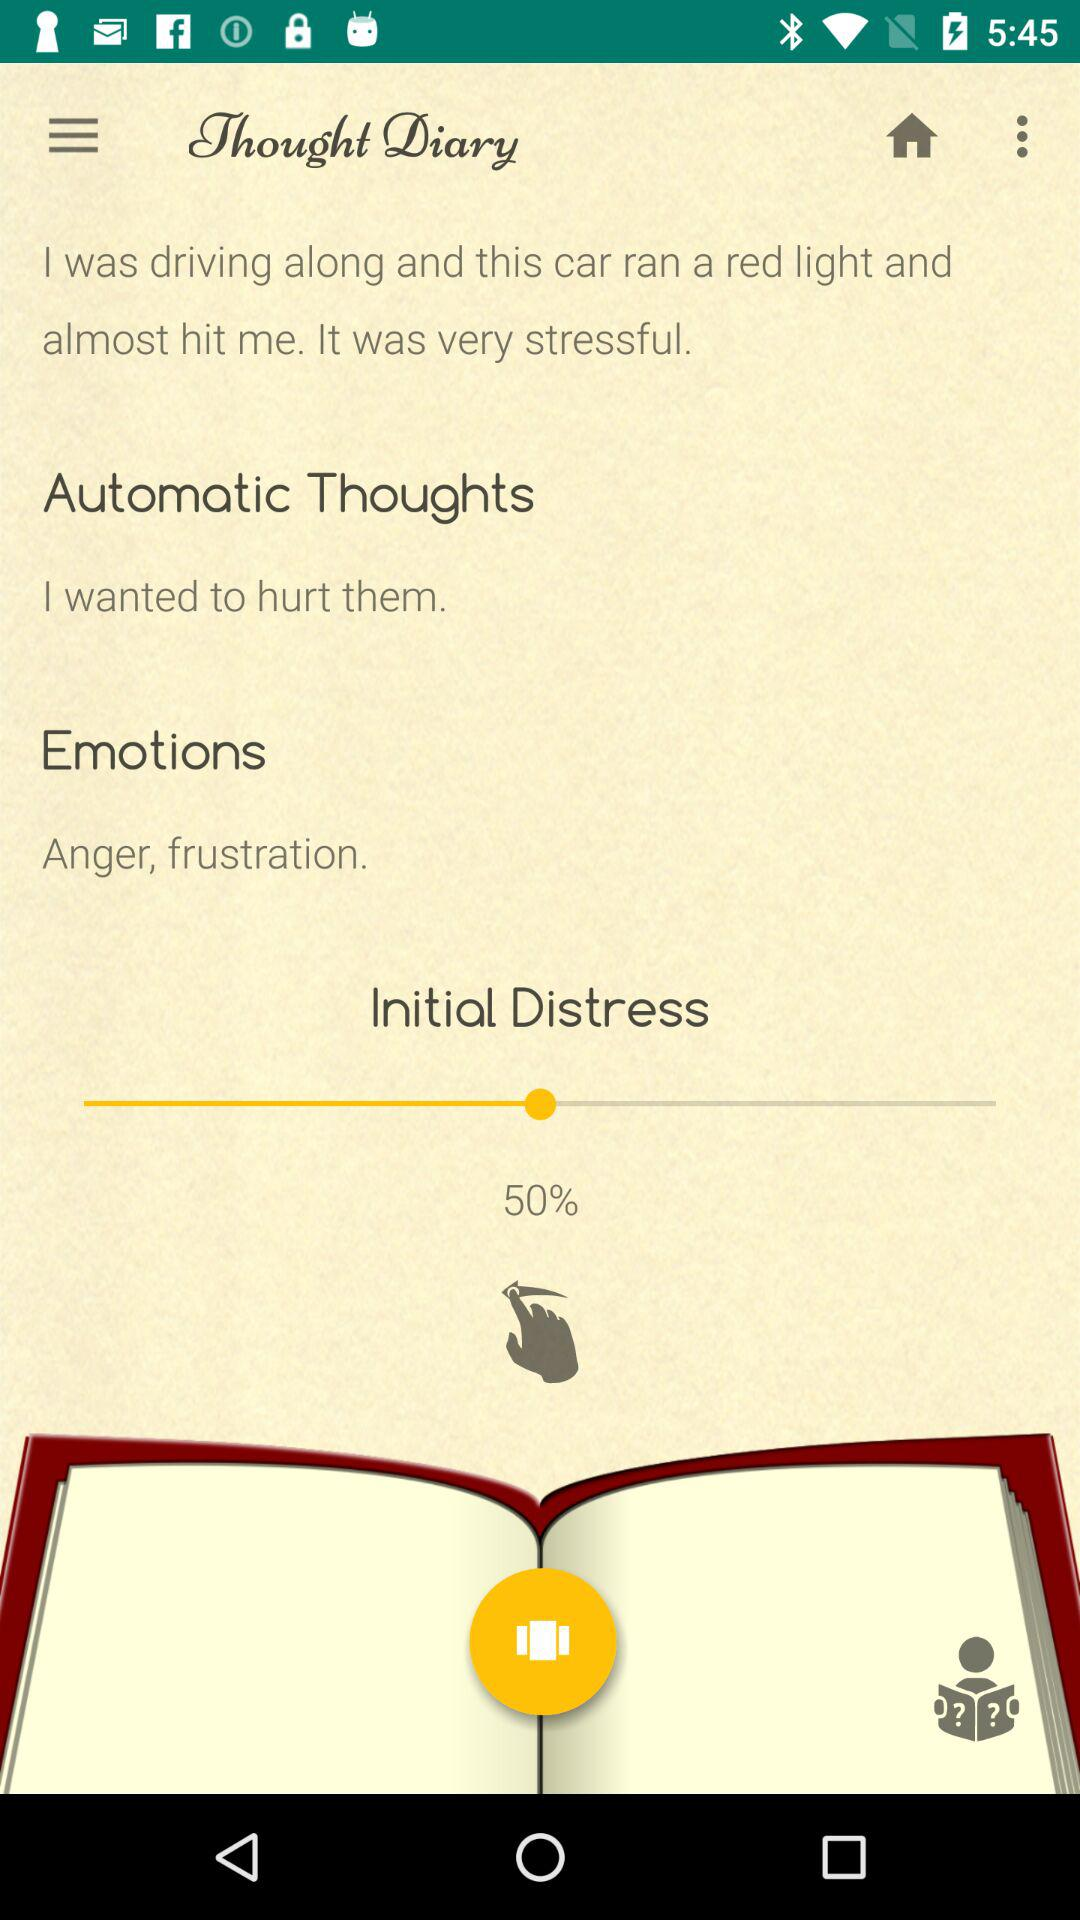What are the emotions? The emotions are anger and frustration. 